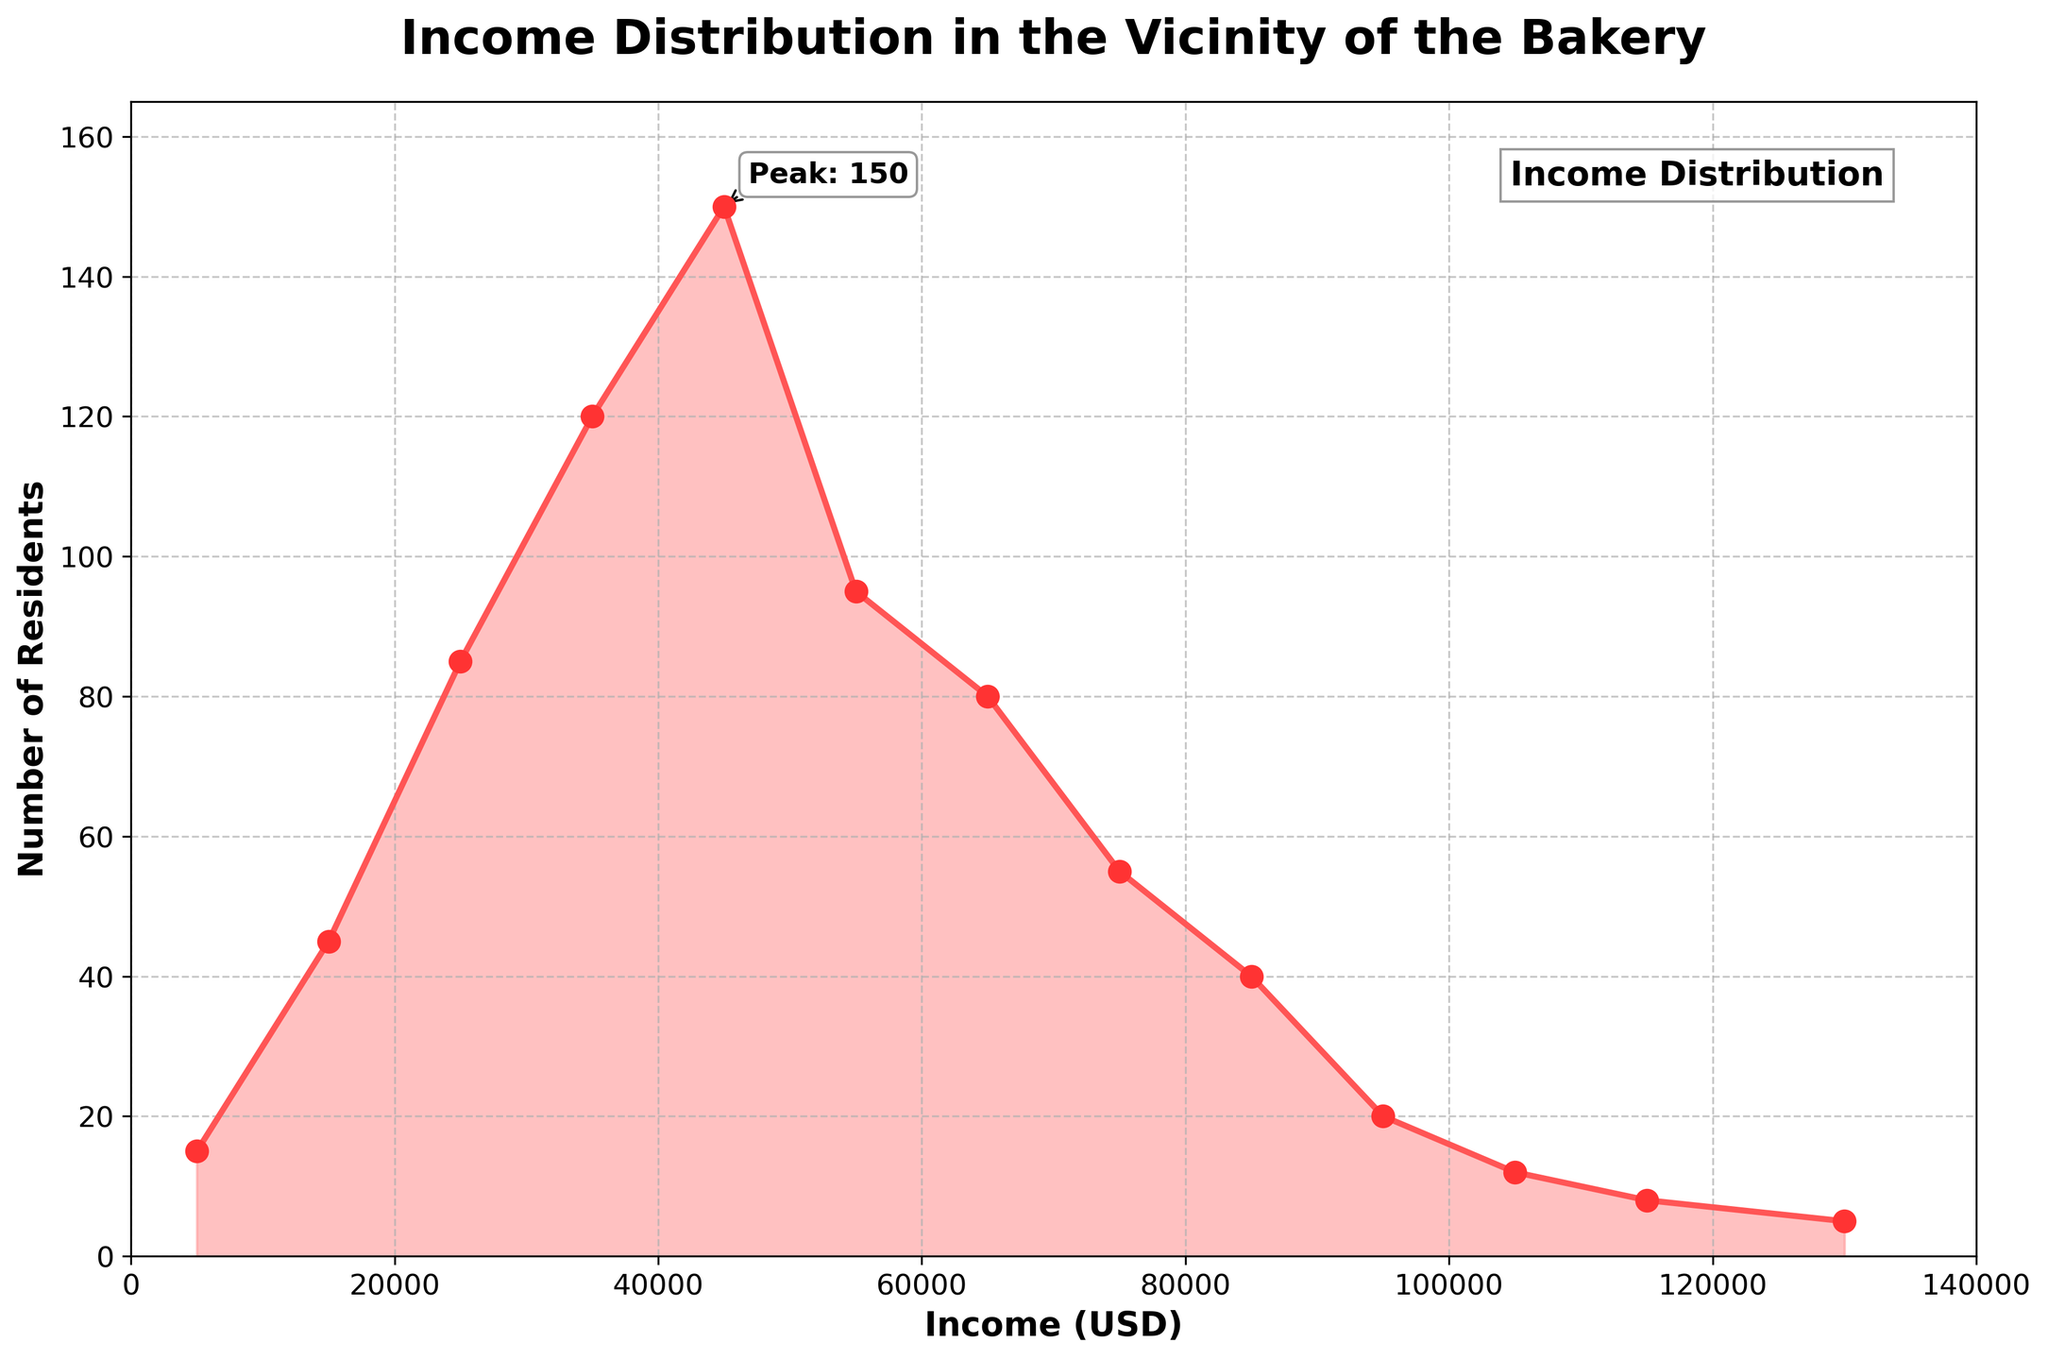What is the title of the plot? The title is clearly placed at the top of the plot as "Income Distribution in the Vicinity of the Bakery".
Answer: Income Distribution in the Vicinity of the Bakery What is the range of the x-axis? The range of the x-axis can be seen by looking at its limits, which spans from $0 to $140,000.
Answer: 0 to 140,000 What income range has the highest number of residents? The plot shows a peak at the income range near $40,000-$50,000, indicated by the highest point of the density curve.
Answer: 40,000-50,000 How many residents have an income of $130,000 or more? The plot shows that the '120,000+' range has exactly 5 residents, which is at the very end of the density plot.
Answer: 5 What is the color of the density area under the curve? The shaded area under the curve is filled with a pink color, which is visually dominant in the plot.
Answer: Pink What is the peak number of residents and at what income? The peak is annotated specifically in the plot as "Peak: 150", occurring at the income range of $40,000-$50,000.
Answer: 150 at $40,000-$50,000 Which income range has a greater number of residents: $50,000-$60,000 or $60,000-$70,000? The plot shows that the $50,000-$60,000 range has a higher point on the density curve compared to the $60,000-$70,000 range.
Answer: $50,000-$60,000 Is the number of residents declining consistently as income increases beyond $50,000? From the density plot, we can see that counts decrease as income increases beyond $50,000, illustrating a downward trend.
Answer: Yes What annotation is present on the plot besides the title and axes labels? There is an annotation next to the peak indicating 'Peak: 150', pointing to the highest count on the plot.
Answer: Peak: 150 From the plot, can we infer if there are significantly more low-income residents than high-income residents? Yes, the plot shows a much higher density in the lower income ranges (0-60,000) compared to the higher income ranges (above 60,000).
Answer: Yes 